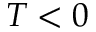Convert formula to latex. <formula><loc_0><loc_0><loc_500><loc_500>T < 0</formula> 